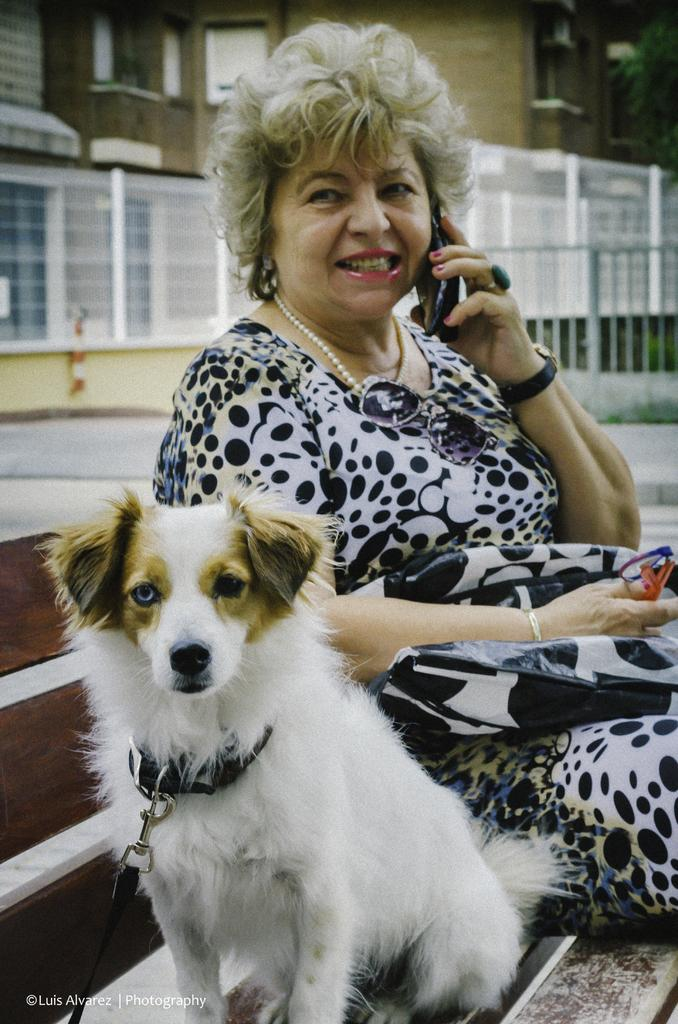Who is present in the image? There is a woman in the image. What other living creature is in the image? There is a dog in the image. Where are the woman and dog sitting? The woman and dog are sitting on a bench. What can be seen in the background of the image? There is a building in the background of the image. How many chickens are present on the bench with the woman and dog? There are no chickens present in the image; it only features a woman and a dog sitting on a bench. 